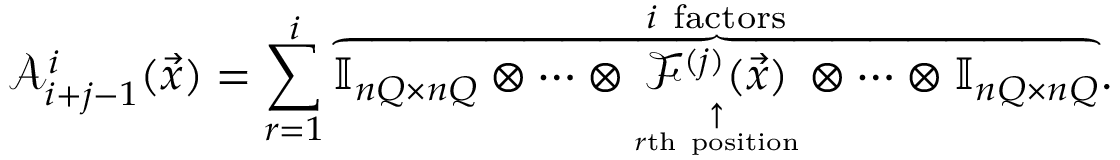<formula> <loc_0><loc_0><loc_500><loc_500>\mathcal { A } _ { i + j - 1 } ^ { i } ( \vec { x } ) = \sum _ { r = 1 } ^ { i } \overset { i f a c t o r s } { \overbrace { { \mathbb { I } _ { n Q \times n Q } } \otimes \cdots \otimes \underset { \underset { r t h p o s i t i o n } { \uparrow } } { \mathcal { F } ^ { ( j ) } ( \vec { x } ) } \otimes \cdots \otimes { \mathbb { I } _ { n Q \times n Q } } } } .</formula> 